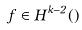Convert formula to latex. <formula><loc_0><loc_0><loc_500><loc_500>f \in H ^ { k - 2 } ( \Omega )</formula> 